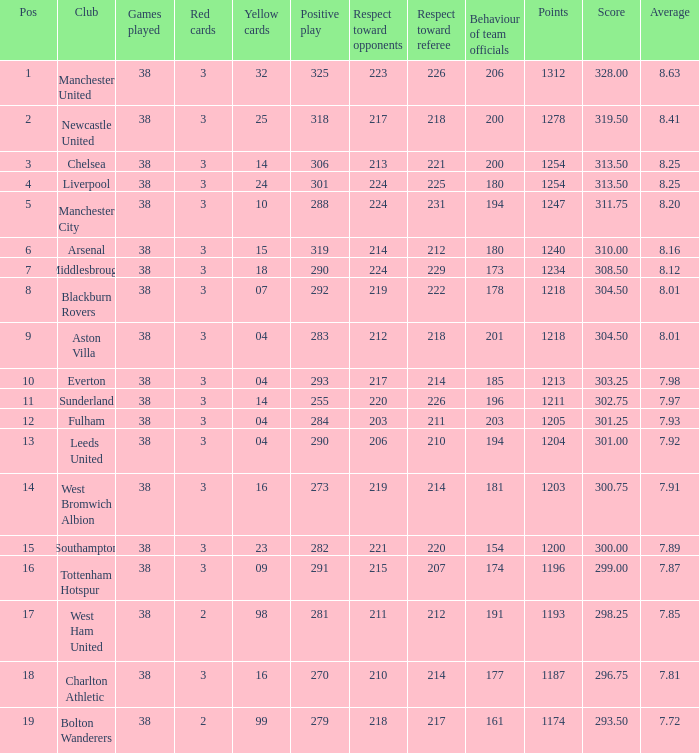Name the points for 212 respect toward opponents 1218.0. 